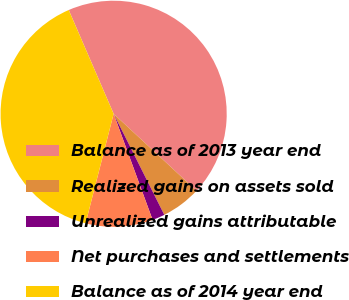<chart> <loc_0><loc_0><loc_500><loc_500><pie_chart><fcel>Balance as of 2013 year end<fcel>Realized gains on assets sold<fcel>Unrealized gains attributable<fcel>Net purchases and settlements<fcel>Balance as of 2014 year end<nl><fcel>43.41%<fcel>5.69%<fcel>1.79%<fcel>9.59%<fcel>39.51%<nl></chart> 